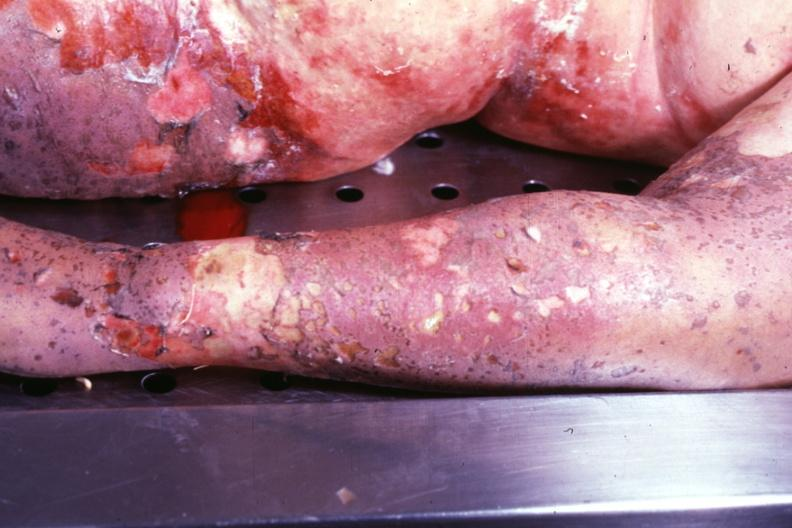where is this?
Answer the question using a single word or phrase. Skin 